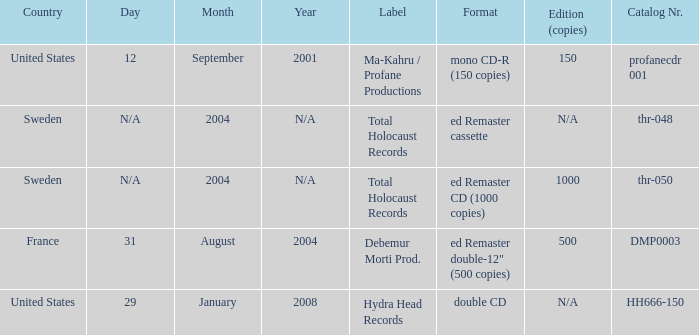Which country has the catalog nr of thr-048 in 2004? Sweden. 